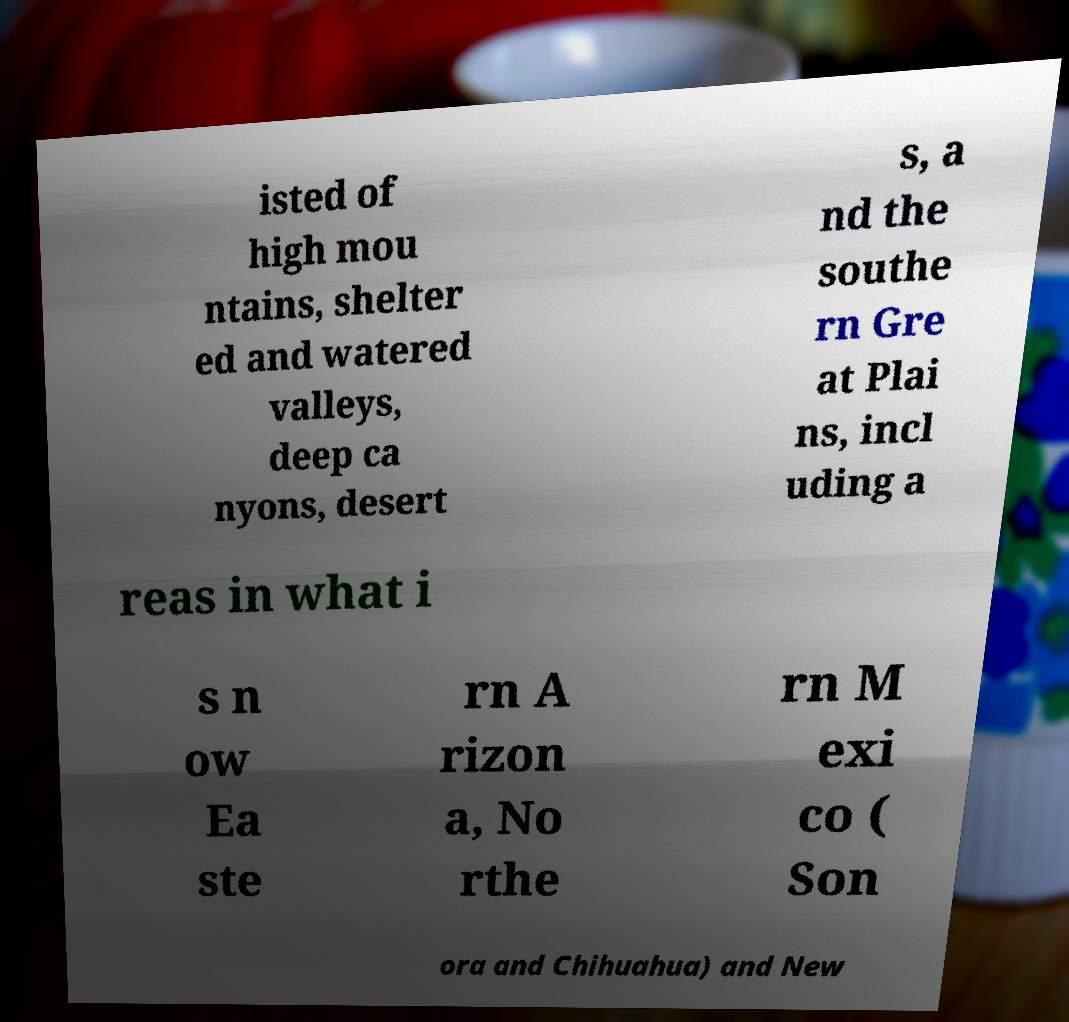Could you extract and type out the text from this image? isted of high mou ntains, shelter ed and watered valleys, deep ca nyons, desert s, a nd the southe rn Gre at Plai ns, incl uding a reas in what i s n ow Ea ste rn A rizon a, No rthe rn M exi co ( Son ora and Chihuahua) and New 